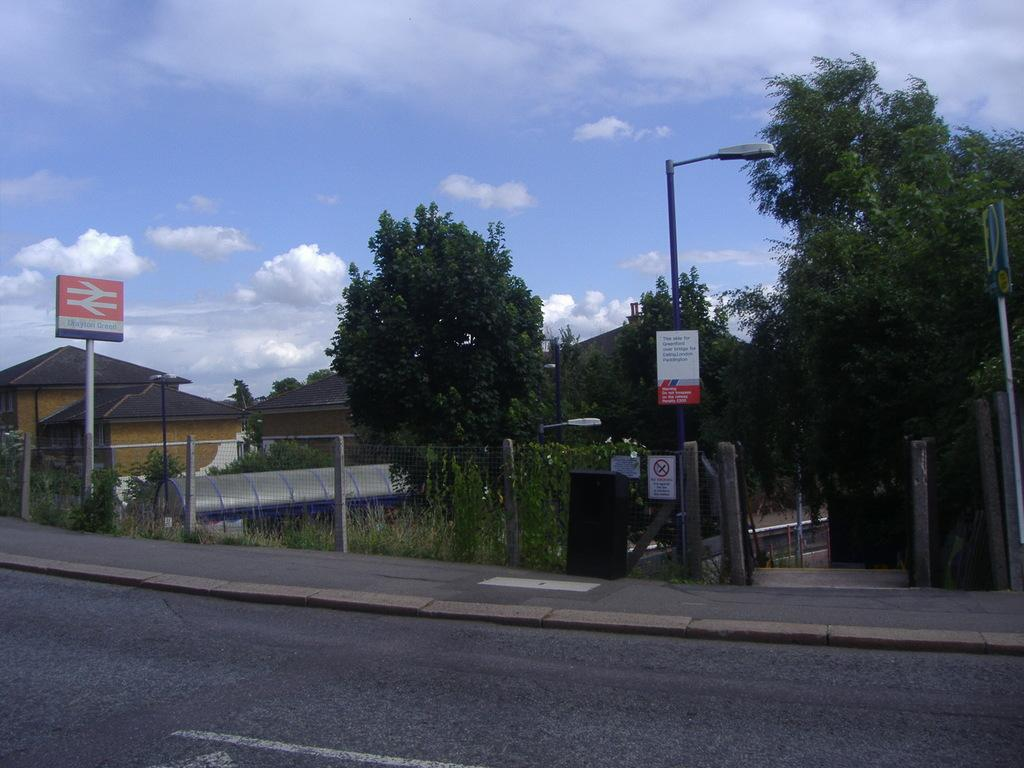What type of natural elements can be seen in the image? There are trees and plants in the image. What man-made structures are present in the image? There are poles, a mesh, a road, instruction boards, and houses in the image. What is the condition of the sky in the image? The sky is cloudy in the image. What type of cart can be seen carrying a nail in the image? There is no cart or nail present in the image. Is there a collar visible on any of the trees or plants in the image? No, there is no collar visible on any of the trees or plants in the image. 